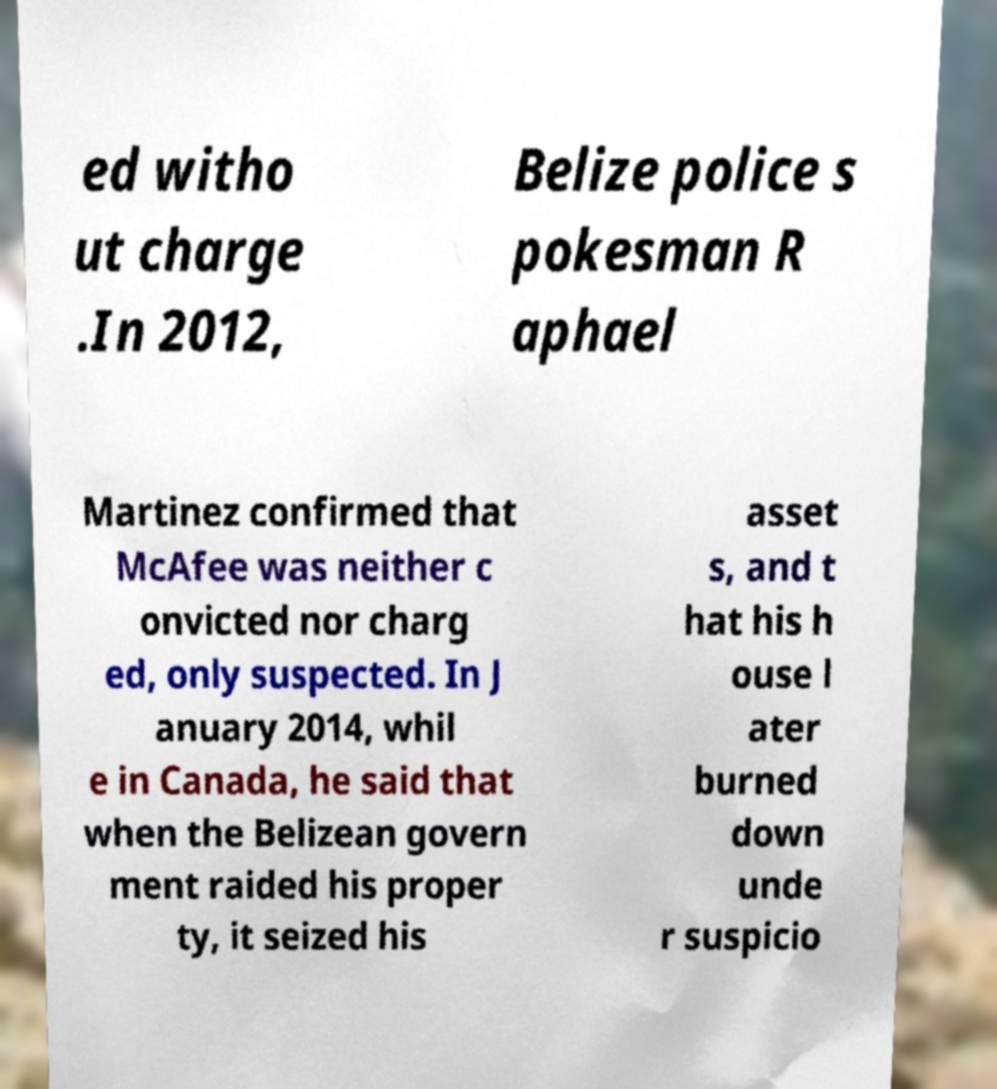Could you extract and type out the text from this image? ed witho ut charge .In 2012, Belize police s pokesman R aphael Martinez confirmed that McAfee was neither c onvicted nor charg ed, only suspected. In J anuary 2014, whil e in Canada, he said that when the Belizean govern ment raided his proper ty, it seized his asset s, and t hat his h ouse l ater burned down unde r suspicio 